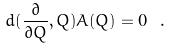Convert formula to latex. <formula><loc_0><loc_0><loc_500><loc_500>d ( \frac { \partial } { \partial Q } , Q ) A ( Q ) = 0 \ .</formula> 